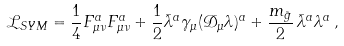Convert formula to latex. <formula><loc_0><loc_0><loc_500><loc_500>\mathcal { L } _ { S Y M } = \frac { 1 } { 4 } F _ { \mu \nu } ^ { a } F _ { \mu \nu } ^ { a } + \frac { 1 } { 2 } { \bar { \lambda } } ^ { a } \gamma _ { \mu } ( \mathcal { D } _ { \mu } \lambda ) ^ { a } + \frac { m _ { \tilde { g } } } { 2 } \, { \bar { \lambda } } ^ { a } \lambda ^ { a } \, ,</formula> 